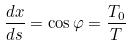<formula> <loc_0><loc_0><loc_500><loc_500>\frac { d x } { d s } = \cos \varphi = \frac { T _ { 0 } } { T }</formula> 